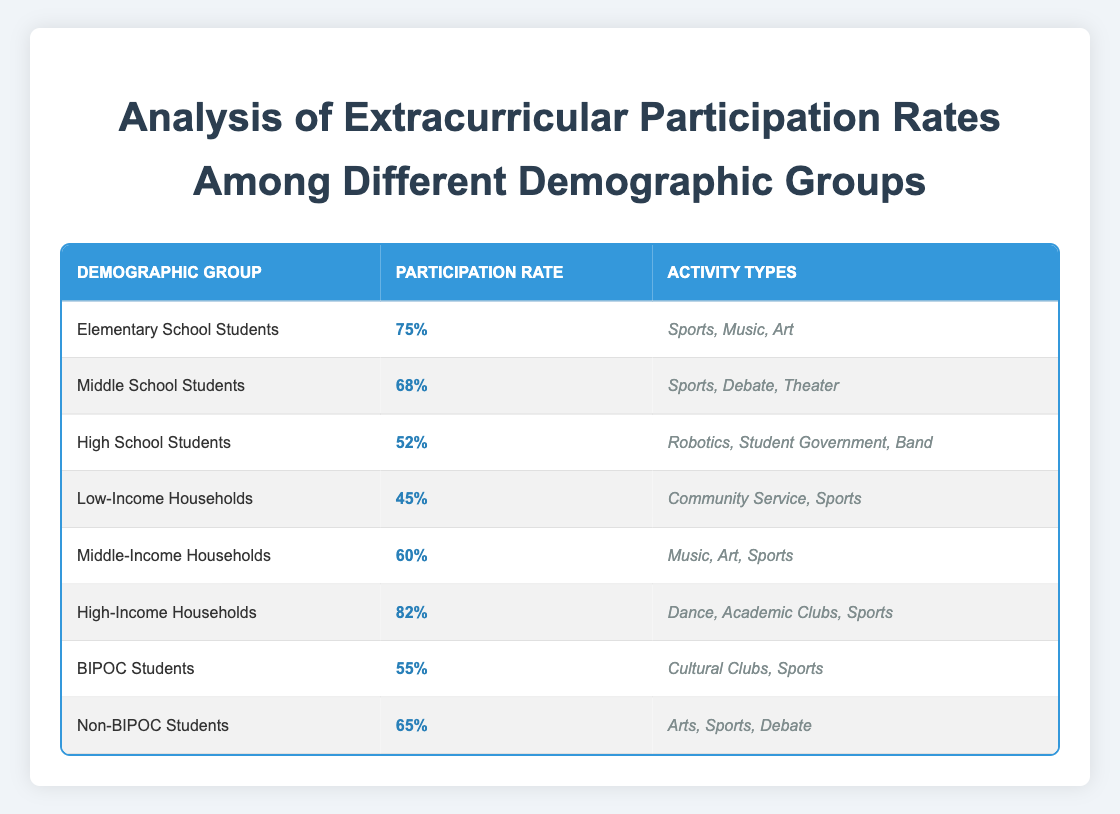What is the participation rate for High School Students? Referring to the table, the row for High School Students specifically states that their participation rate is 52%.
Answer: 52% Which demographic group has the highest participation rate? By examining the table, High-Income Households has the highest participation rate at 82%, compared to other groups listed.
Answer: High-Income Households What activities can Middle School Students participate in? The table indicates that Middle School Students can participate in Sports, Debate, and Theater, as shown in their respective row.
Answer: Sports, Debate, Theater What is the difference in participation rates between Elementary School Students and Low-Income Households? The participation rate for Elementary School Students is 75%, and for Low-Income Households, it is 45%. To find the difference: 75 - 45 = 30. Thus, the difference is 30%.
Answer: 30% Is the participation rate for Non-BIPOC Students greater than 60%? Checking the table, Non-BIPOC Students have a participation rate of 65%, which is greater than 60%. Therefore, the answer is yes.
Answer: Yes What are the average participation rates for all household income groups? The participation rates for the income groups are: Low-Income (45%), Middle-Income (60%), and High-Income (82%). To calculate the average: (45 + 60 + 82) / 3 = 62.33, rounding gives approximately 62%.
Answer: 62% Do BIPOC Students participate in more activity types compared to High School Students? BIPOC Students participate in 2 activities (Cultural Clubs, Sports) while High School Students participate in 3 activities (Robotics, Student Government, Band). Therefore, BIPOC Students participate in fewer types overall.
Answer: No Which demographic group has a participation rate less than 50%? Looking through the table rows, Low-Income Households is the only group with a participation rate below 50%, specifically at 45%.
Answer: Low-Income Households 